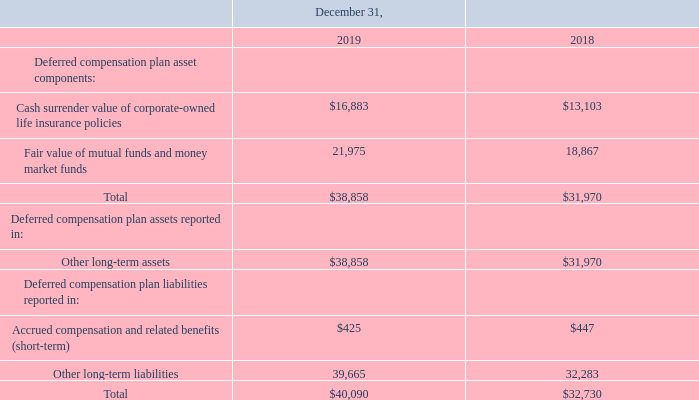Deferred Compensation Plan
The Company has a non-qualified, unfunded deferred compensation plan, which provides certain key employees, including executive officers, with the ability to defer the receipt of compensation in order to accumulate funds for retirement on a tax deferred basis. The Company does not make contributions to the plan or guarantee returns on the investments. The Company is responsible for the plan’s administrative expenses. Participants’ deferrals and investment gains and losses remain as the Company’s liabilities and the underlying assets are subject to claims of general creditors.
The liabilities for compensation deferred under the plan are recorded at fair value in each reporting period. Changes in the fair value of the liabilities are included in operating expense on the Consolidated Statements of Operations. The Company manages the risk of changes in the fair value of the liabilities by electing to match the liabilities with investments in corporate-owned life insurance policies, mutual funds and money market funds that offset a substantial portion of the exposure. The investments are recorded at the cash surrender value of the corporate-owned life insurance policies, and at the fair value of the mutual funds and money market funds, which are classified as trading securities. Changes in the cash surrender value of the corporate-owned life insurance policies and the fair value of mutual fund and money market fund investments are included in interest and other income, net on the Consolidated Statements of Operations. The following table summarizes the deferred compensation plan balances on the Consolidated Balance Sheets (in thousands):
What was the total deferred compensation plan asset components in 2018 and 2019 respectively?
Answer scale should be: thousand. 31,970, 38,858. Does the company make contributions to the non-qualified, unfunded deferred compensation plan or guarantee returns on investments? Does not make contributions to the plan or guarantee returns on the investments. Where can changes in the fair value of the liabilities be found? Operating expense on the consolidated statements of operations. What was the change in Cash surrender value of corporate-owned life insurance policies from 2018 to 2019?
Answer scale should be: thousand. 16,883-13,103
Answer: 3780. What was the percentage change in amount spent on other long-term liabilities from 2018 to 2019?
Answer scale should be: percent. (39,665-32,283)/32,283
Answer: 22.87. Which year had a higher total liability?  $40,090> $32,730 
Answer: 2019. 